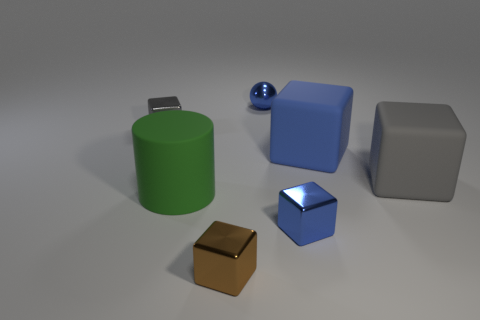Subtract all tiny shiny blocks. How many blocks are left? 2 Add 2 tiny green shiny balls. How many objects exist? 9 Subtract all yellow cylinders. How many gray blocks are left? 2 Subtract 2 blocks. How many blocks are left? 3 Subtract all blocks. How many objects are left? 2 Subtract all gray blocks. How many blocks are left? 3 Subtract 0 purple cylinders. How many objects are left? 7 Subtract all yellow spheres. Subtract all green cylinders. How many spheres are left? 1 Subtract all blue cubes. Subtract all large rubber objects. How many objects are left? 2 Add 2 gray matte blocks. How many gray matte blocks are left? 3 